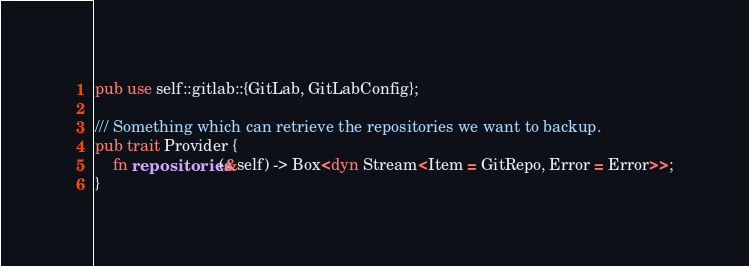<code> <loc_0><loc_0><loc_500><loc_500><_Rust_>pub use self::gitlab::{GitLab, GitLabConfig};

/// Something which can retrieve the repositories we want to backup.
pub trait Provider {
    fn repositories(&self) -> Box<dyn Stream<Item = GitRepo, Error = Error>>;
}
</code> 